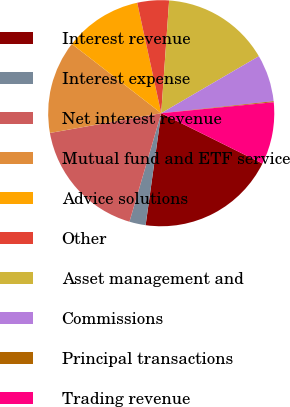Convert chart. <chart><loc_0><loc_0><loc_500><loc_500><pie_chart><fcel>Interest revenue<fcel>Interest expense<fcel>Net interest revenue<fcel>Mutual fund and ETF service<fcel>Advice solutions<fcel>Other<fcel>Asset management and<fcel>Commissions<fcel>Principal transactions<fcel>Trading revenue<nl><fcel>19.86%<fcel>2.33%<fcel>17.67%<fcel>13.29%<fcel>11.1%<fcel>4.52%<fcel>15.48%<fcel>6.71%<fcel>0.14%<fcel>8.9%<nl></chart> 